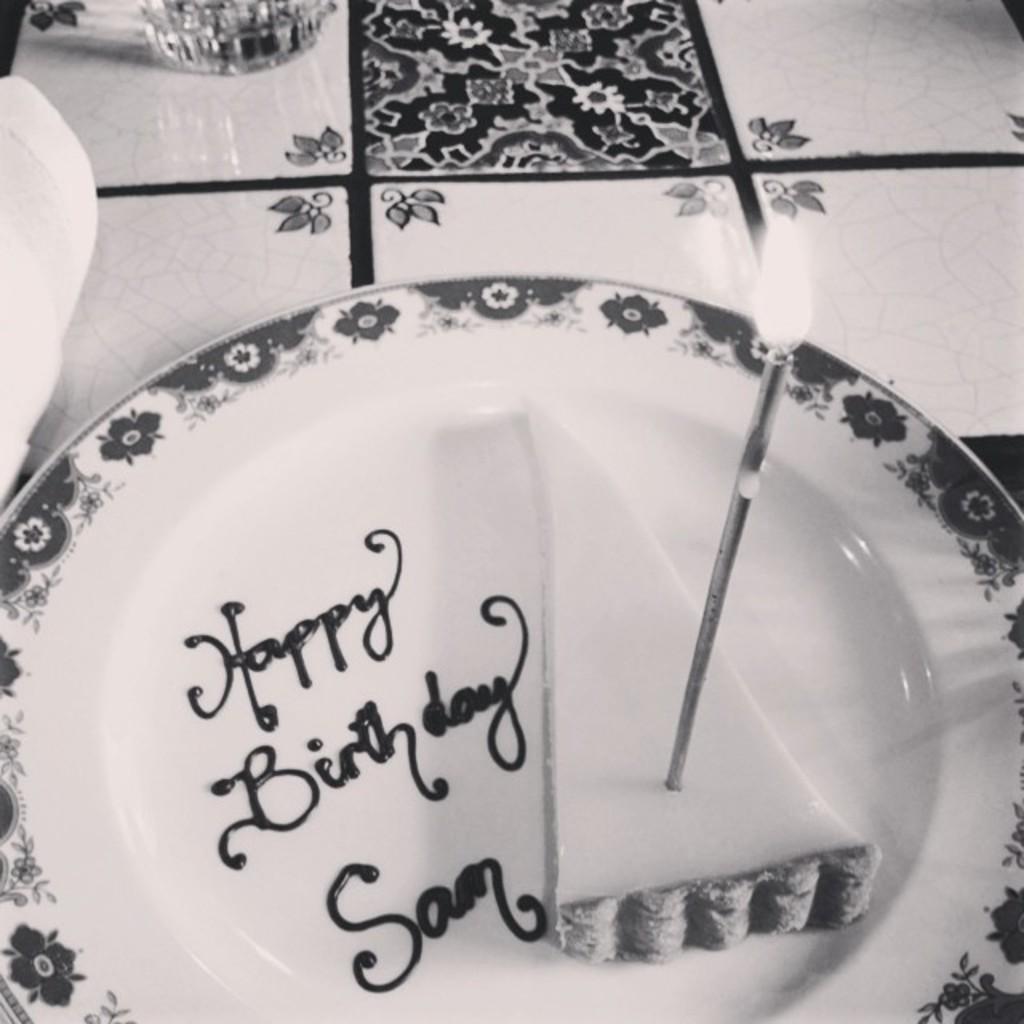Describe this image in one or two sentences. This is a black and white image. We can see a candle with flame on a cake piece and text written with cream on the plate on the platform and we can see an object and glass on the platform. 